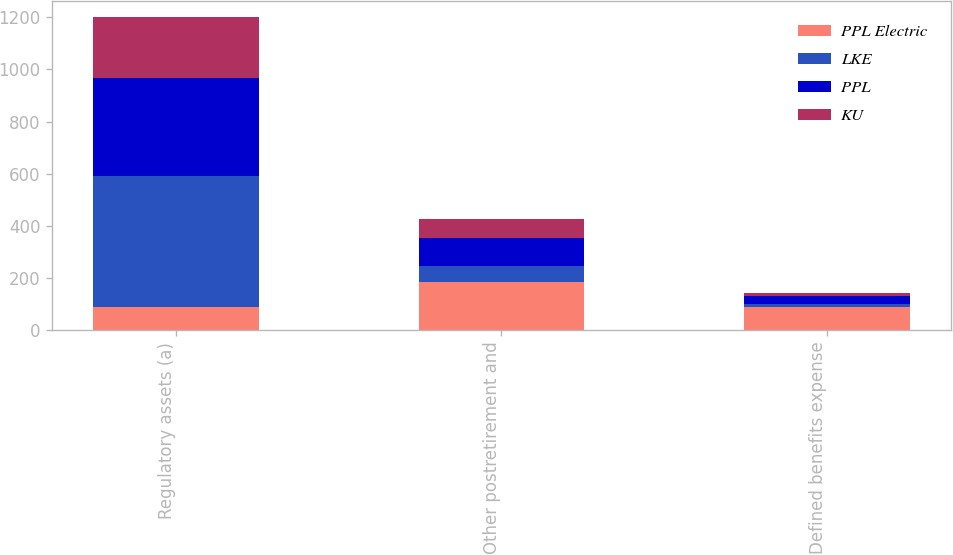Convert chart to OTSL. <chart><loc_0><loc_0><loc_500><loc_500><stacked_bar_chart><ecel><fcel>Regulatory assets (a)<fcel>Other postretirement and<fcel>Defined benefits expense<nl><fcel>PPL Electric<fcel>87<fcel>184<fcel>87<nl><fcel>LKE<fcel>504<fcel>62<fcel>12<nl><fcel>PPL<fcel>376<fcel>107<fcel>33<nl><fcel>KU<fcel>234<fcel>74<fcel>11<nl></chart> 